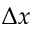<formula> <loc_0><loc_0><loc_500><loc_500>\Delta x</formula> 